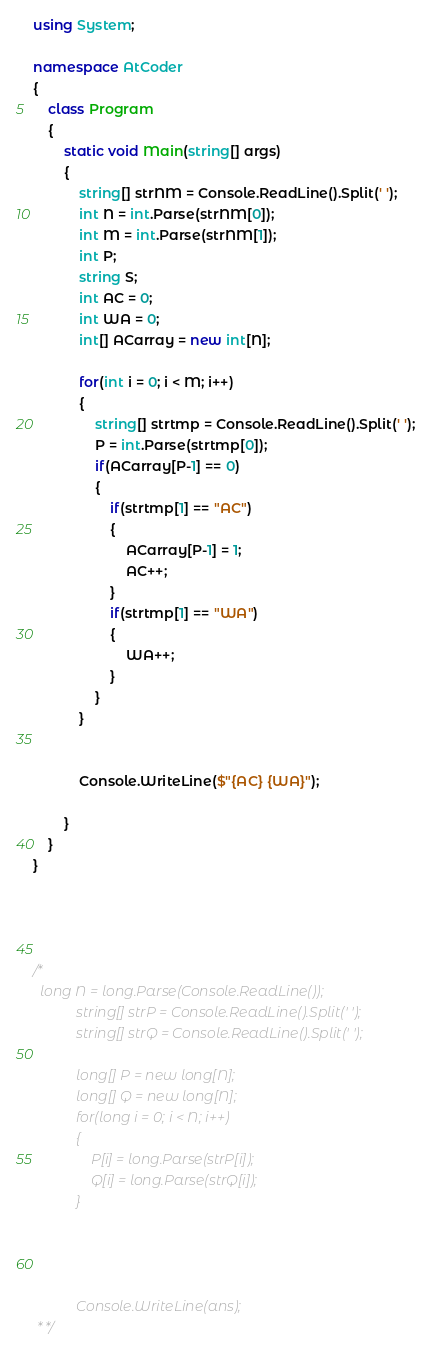Convert code to text. <code><loc_0><loc_0><loc_500><loc_500><_C#_>using System;

namespace AtCoder
{
    class Program
    {
        static void Main(string[] args)
        {
            string[] strNM = Console.ReadLine().Split(' ');
            int N = int.Parse(strNM[0]);
            int M = int.Parse(strNM[1]);
            int P;
            string S;
            int AC = 0;
            int WA = 0;
            int[] ACarray = new int[N];

            for(int i = 0; i < M; i++)
            {
                string[] strtmp = Console.ReadLine().Split(' ');
                P = int.Parse(strtmp[0]);
                if(ACarray[P-1] == 0)
                {
                    if(strtmp[1] == "AC")
                    {
                        ACarray[P-1] = 1;
                        AC++;
                    }
                    if(strtmp[1] == "WA")
                    {
                        WA++;
                    }
                }
            }


            Console.WriteLine($"{AC} {WA}");

        }
    }
}




/*
  long N = long.Parse(Console.ReadLine());
            string[] strP = Console.ReadLine().Split(' ');
            string[] strQ = Console.ReadLine().Split(' ');

            long[] P = new long[N];
            long[] Q = new long[N];
            for(long i = 0; i < N; i++)
            {
                P[i] = long.Parse(strP[i]);
                Q[i] = long.Parse(strQ[i]);
            }




            Console.WriteLine(ans);
 * */
</code> 